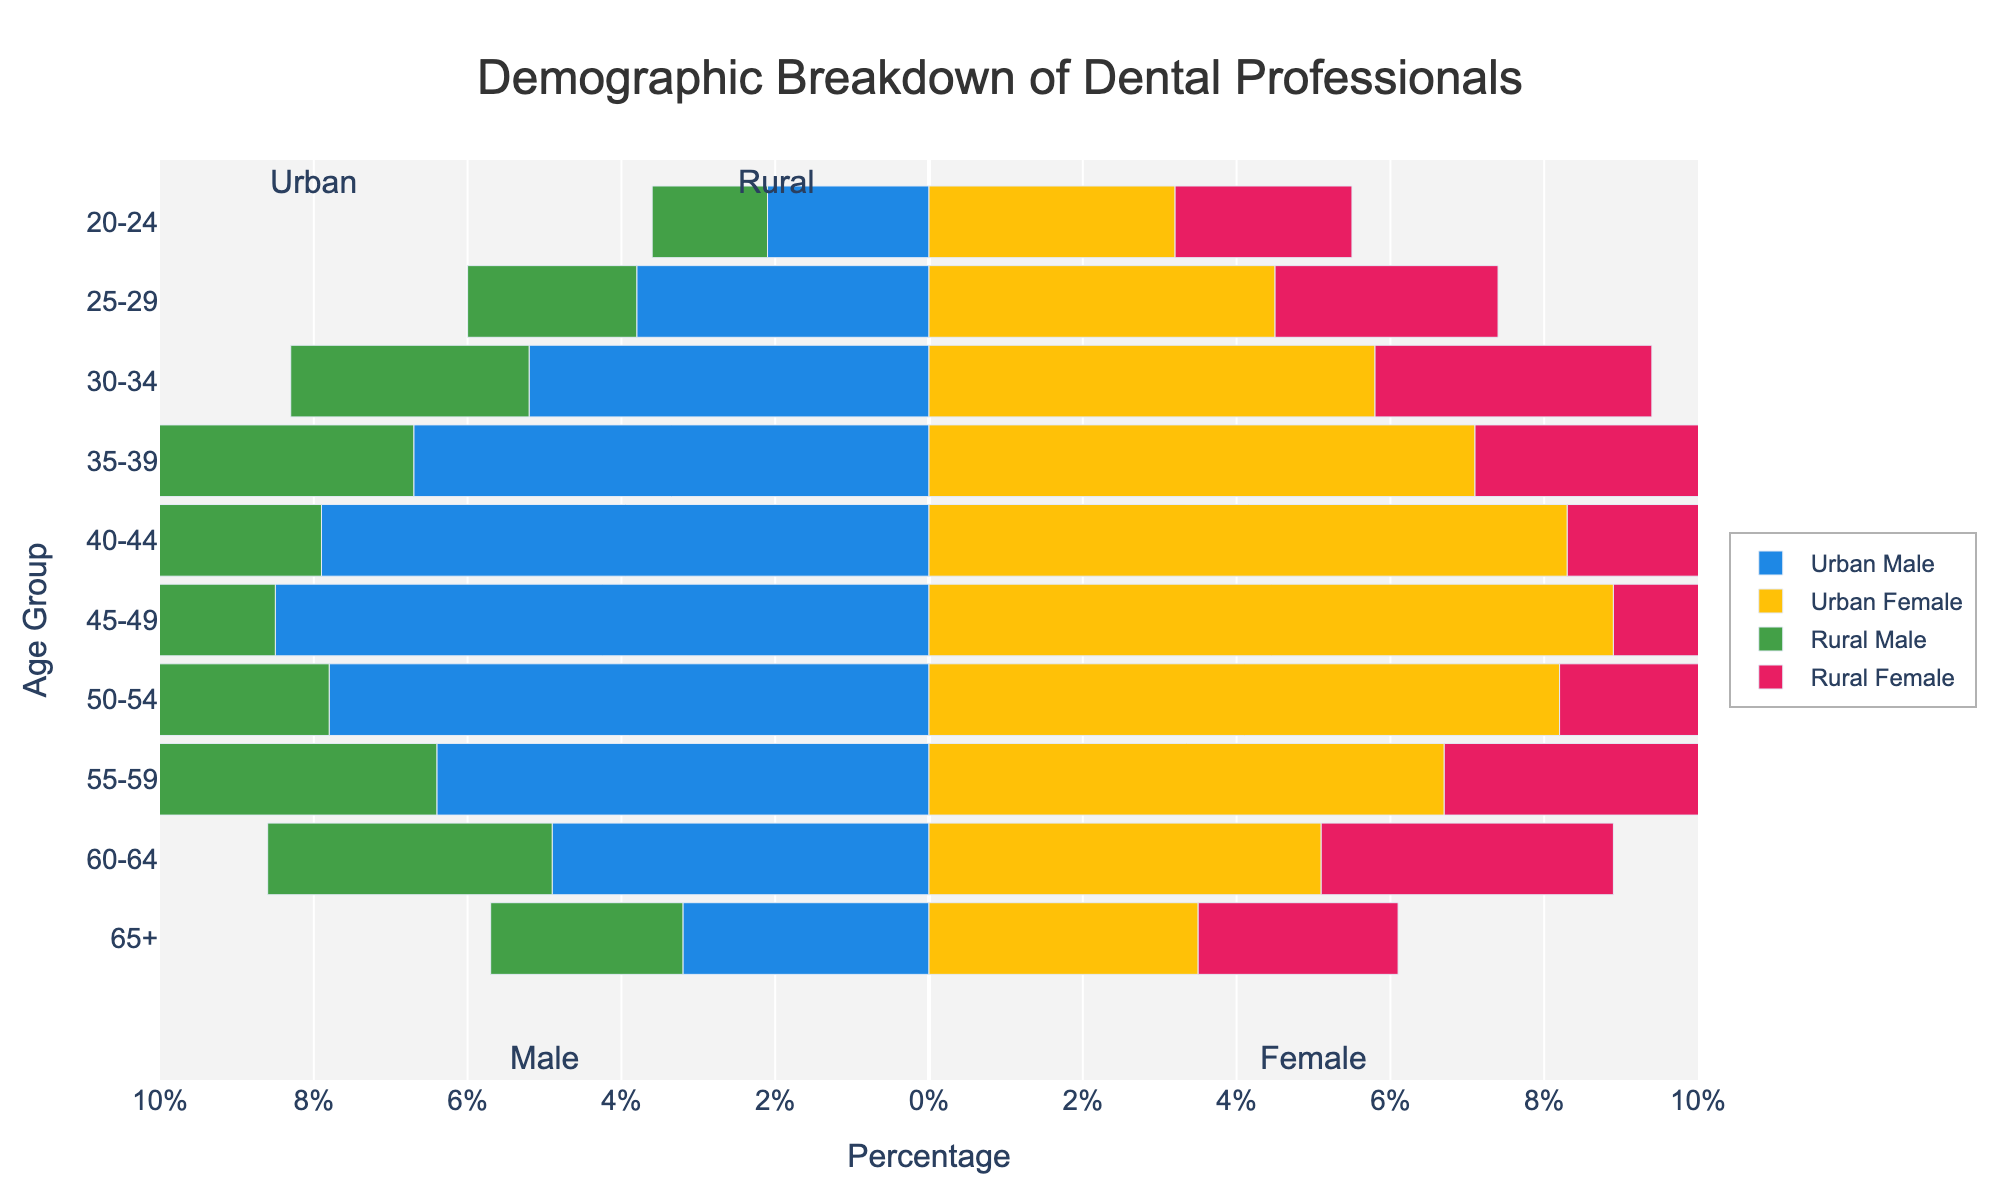What is the title of the plot? The title of the plot is located at the top of the figure and reads "Demographic Breakdown of Dental Professionals".
Answer: Demographic Breakdown of Dental Professionals Which gender and location category has the highest percentage of dental professionals in the 45-49 age group? The percentage values for the 45-49 age group are displayed by the horizontal length of the bars. For the 45-49 age group, Urban Female shows the longest bar.
Answer: Urban Female What is the combined percentage of urban and rural male dental professionals in the 30-34 age group? The figure shows the urban male percentage as -5.2% and the rural male percentage as -3.1% for the 30-34 age group. Summing these values gives (-5.2 + (-3.1)) = -8.3%. Since the percentages are shown as negatives for males, their absolute combined value is 8.3%.
Answer: 8.3% In which age group do urban female dental professionals outnumber rural female dental professionals the most? By comparing the length of the bars in each age group, the difference between urban and rural female percentages is largest in the 45-49 age group, where Urban Female is 8.9% and Rural Female is 6.1%, a difference of 2.8%.
Answer: 45-49 Which age group has the smallest percentage of rural female dental professionals? By looking at the length of the pink bars for rural females across age groups, the 20-24 age group has the smallest bar at 2.3%.
Answer: 20-24 How does the demographic distribution of urban males compare to urban females in the 60-64 age group? For the 60-64 age group, the blue bar for urban males is -4.9% and the yellow bar for urban females is 5.1%. The urban female percentage is slightly higher.
Answer: Urban females are slightly higher Is the percentage of dental professionals higher in urban areas or rural areas for the 50-54 age group? For the 50-54 age group, comparing the lengths of urban male (-7.8%) and urban female (8.2%) to rural male (-5.5%) and rural female (5.7%), the combined percentage for urban is higher.
Answer: Higher in urban areas What is the main gender distribution trend for dental professionals across age groups? The plot's divisions and colors inform us that males generally have a lower presence compared to females across most age groups in both urban and rural areas, as noted by the shorter bars on the left (blue and green) compared to the right (yellow and pink).
Answer: Females generally outnumber males Which location has a more uniform distribution of dental professionals across all age groups? Comparing the lengths of the bars across all age groups for urban (blue and yellow) and rural (green and pink) areas, urban areas show more uniformity without sharp declines or peaks in any age group.
Answer: Urban areas 